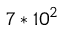Convert formula to latex. <formula><loc_0><loc_0><loc_500><loc_500>7 \ast 1 0 ^ { 2 }</formula> 